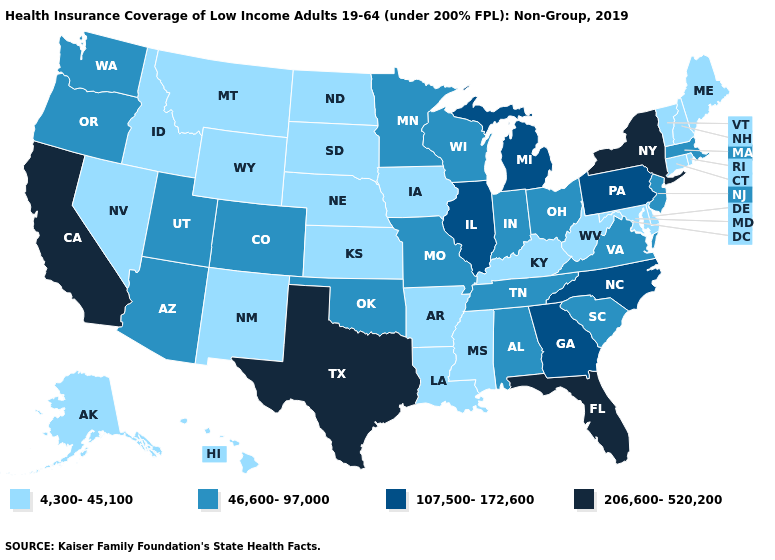Name the states that have a value in the range 46,600-97,000?
Quick response, please. Alabama, Arizona, Colorado, Indiana, Massachusetts, Minnesota, Missouri, New Jersey, Ohio, Oklahoma, Oregon, South Carolina, Tennessee, Utah, Virginia, Washington, Wisconsin. Among the states that border New Jersey , which have the highest value?
Quick response, please. New York. Does the map have missing data?
Quick response, please. No. What is the lowest value in states that border New Mexico?
Quick response, please. 46,600-97,000. Is the legend a continuous bar?
Short answer required. No. What is the value of Hawaii?
Be succinct. 4,300-45,100. Name the states that have a value in the range 206,600-520,200?
Give a very brief answer. California, Florida, New York, Texas. What is the lowest value in the South?
Give a very brief answer. 4,300-45,100. Which states hav the highest value in the MidWest?
Quick response, please. Illinois, Michigan. Among the states that border Nebraska , does Kansas have the lowest value?
Keep it brief. Yes. What is the value of Wyoming?
Keep it brief. 4,300-45,100. What is the value of Alaska?
Quick response, please. 4,300-45,100. Among the states that border Missouri , which have the lowest value?
Quick response, please. Arkansas, Iowa, Kansas, Kentucky, Nebraska. What is the highest value in the USA?
Short answer required. 206,600-520,200. Does the map have missing data?
Concise answer only. No. 